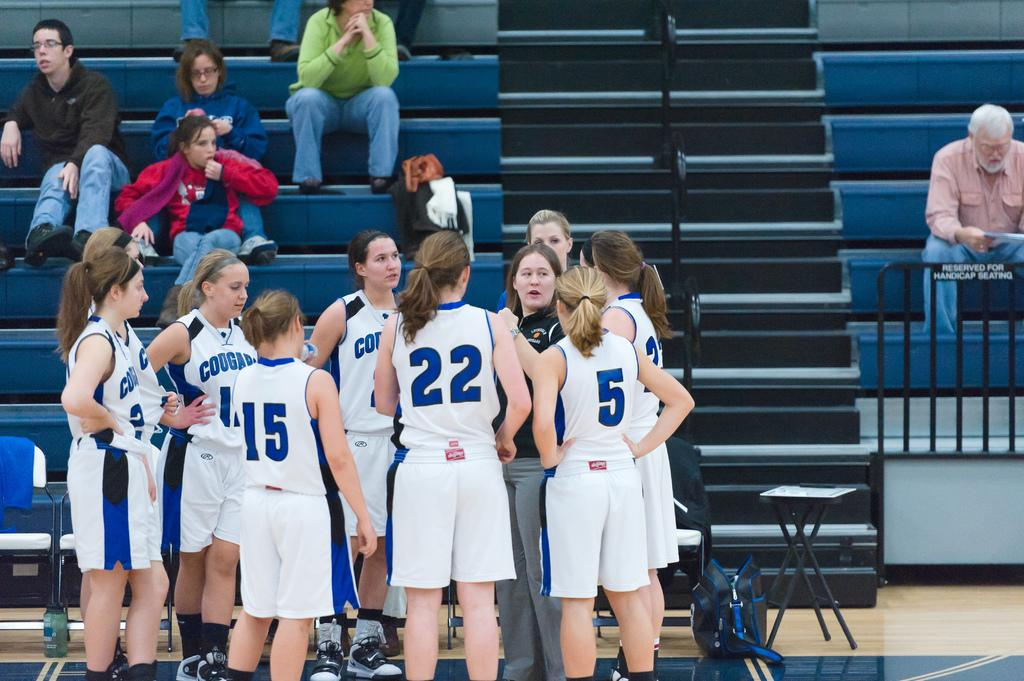<image>
Offer a succinct explanation of the picture presented. Basketball players including numbers 15 and 22 standing in a huddle. 